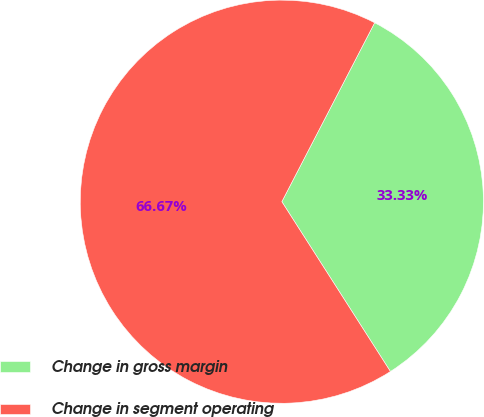Convert chart. <chart><loc_0><loc_0><loc_500><loc_500><pie_chart><fcel>Change in gross margin<fcel>Change in segment operating<nl><fcel>33.33%<fcel>66.67%<nl></chart> 